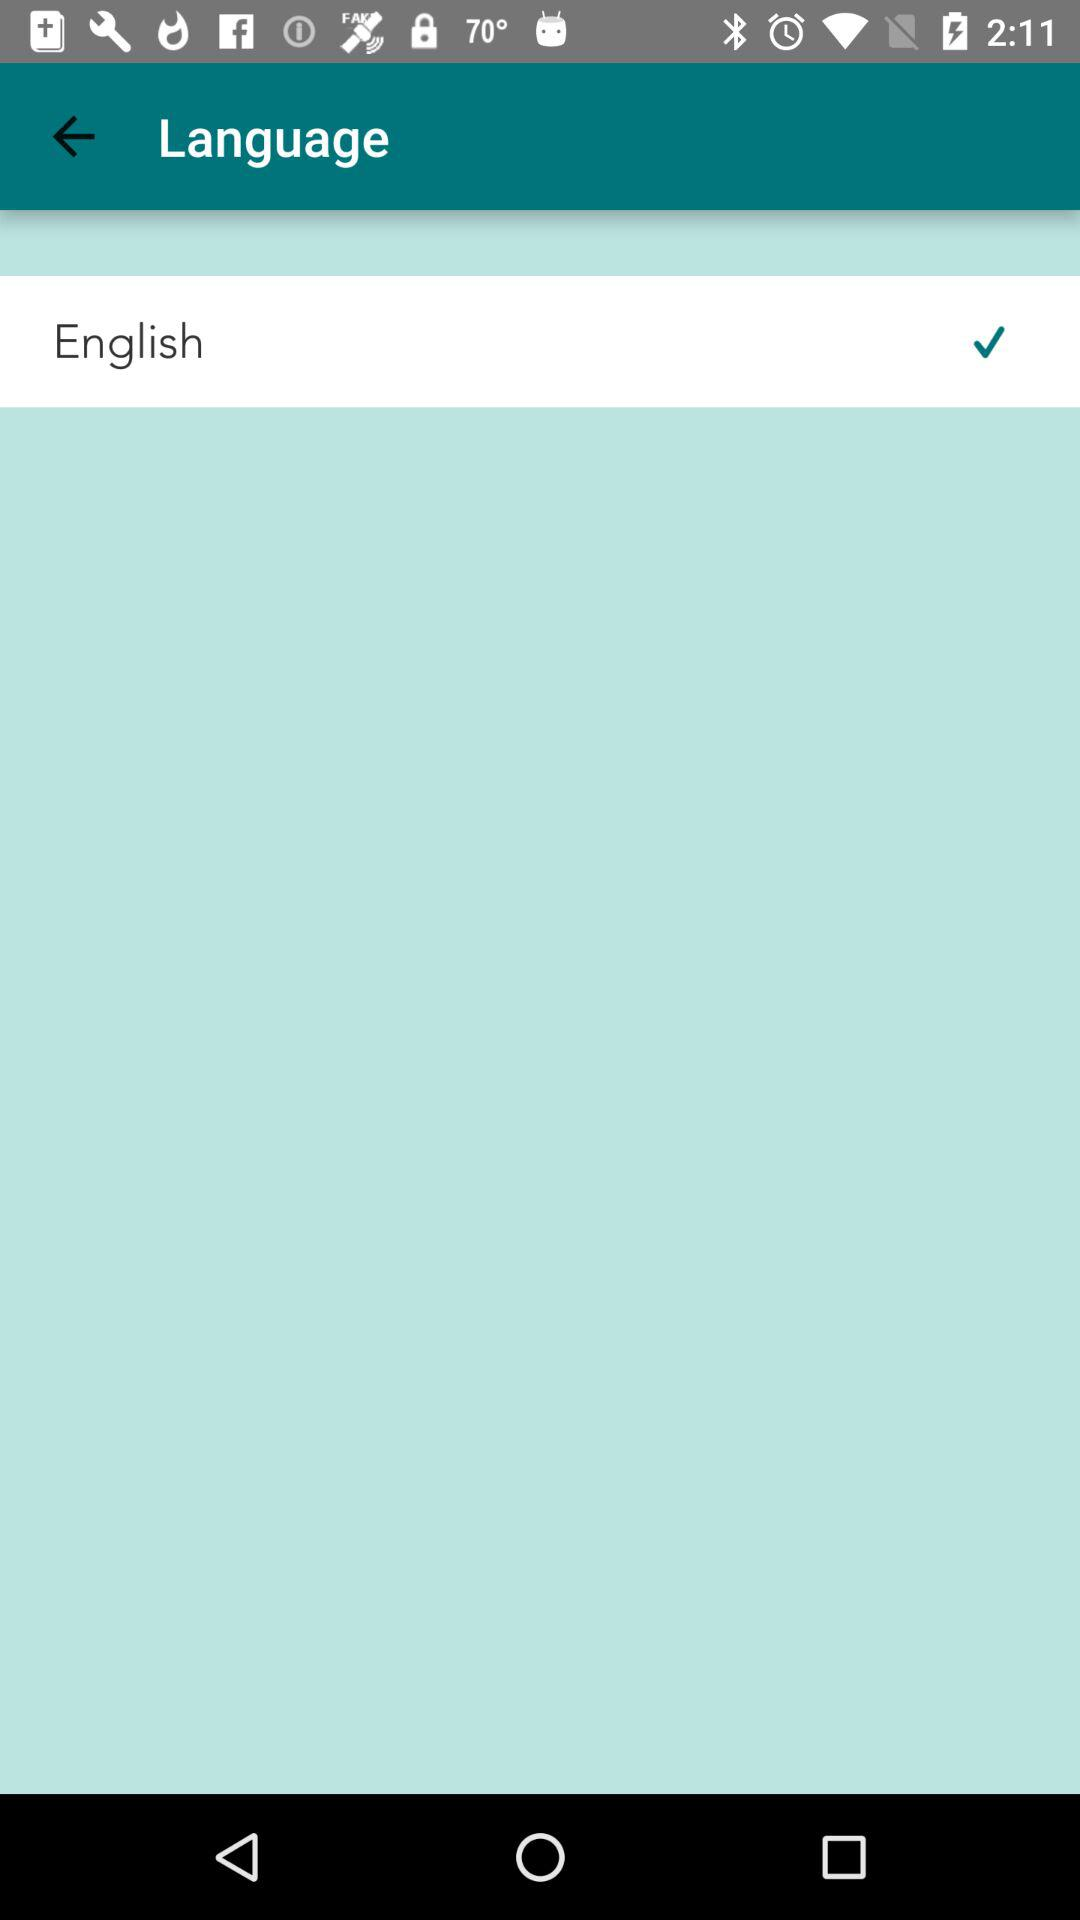What language is selected? The selected language is English. 